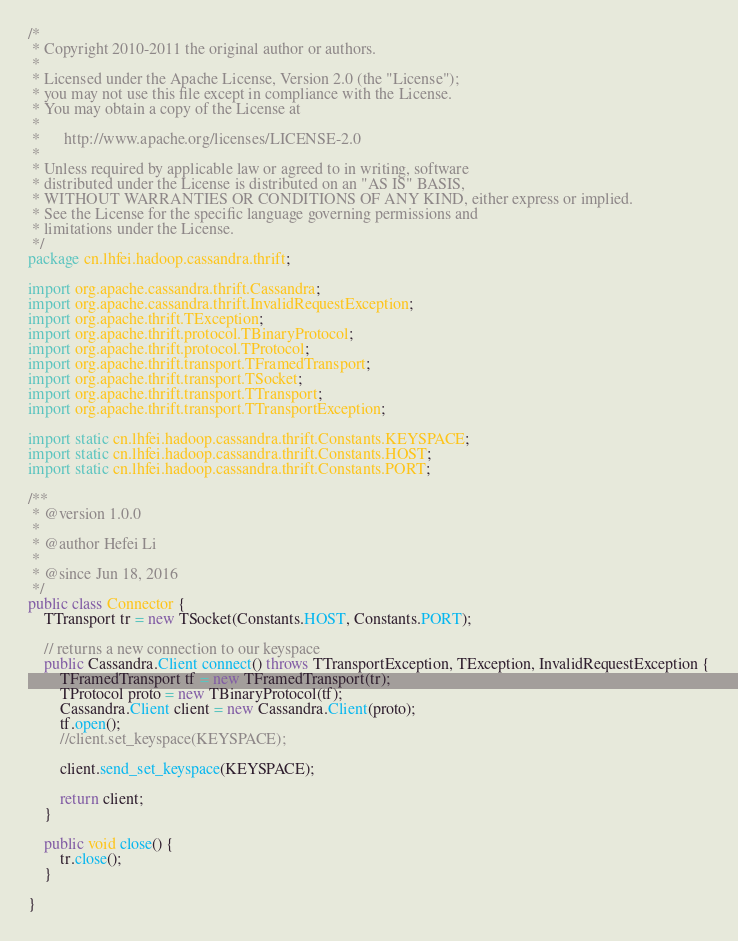Convert code to text. <code><loc_0><loc_0><loc_500><loc_500><_Java_>/*
 * Copyright 2010-2011 the original author or authors.
 *
 * Licensed under the Apache License, Version 2.0 (the "License");
 * you may not use this file except in compliance with the License.
 * You may obtain a copy of the License at
 *
 *      http://www.apache.org/licenses/LICENSE-2.0
 *
 * Unless required by applicable law or agreed to in writing, software
 * distributed under the License is distributed on an "AS IS" BASIS,
 * WITHOUT WARRANTIES OR CONDITIONS OF ANY KIND, either express or implied.
 * See the License for the specific language governing permissions and
 * limitations under the License.
 */
package cn.lhfei.hadoop.cassandra.thrift;

import org.apache.cassandra.thrift.Cassandra;
import org.apache.cassandra.thrift.InvalidRequestException;
import org.apache.thrift.TException;
import org.apache.thrift.protocol.TBinaryProtocol;
import org.apache.thrift.protocol.TProtocol;
import org.apache.thrift.transport.TFramedTransport;
import org.apache.thrift.transport.TSocket;
import org.apache.thrift.transport.TTransport;
import org.apache.thrift.transport.TTransportException;

import static cn.lhfei.hadoop.cassandra.thrift.Constants.KEYSPACE;
import static cn.lhfei.hadoop.cassandra.thrift.Constants.HOST;
import static cn.lhfei.hadoop.cassandra.thrift.Constants.PORT;

/**
 * @version 1.0.0
 *
 * @author Hefei Li
 *
 * @since Jun 18, 2016
 */
public class Connector {
	TTransport tr = new TSocket(Constants.HOST, Constants.PORT);

	// returns a new connection to our keyspace
	public Cassandra.Client connect() throws TTransportException, TException, InvalidRequestException {
		TFramedTransport tf = new TFramedTransport(tr);
		TProtocol proto = new TBinaryProtocol(tf);
		Cassandra.Client client = new Cassandra.Client(proto);
		tf.open();
		//client.set_keyspace(KEYSPACE);

		client.send_set_keyspace(KEYSPACE);

		return client;
	}

	public void close() {
		tr.close();
	}

}
</code> 